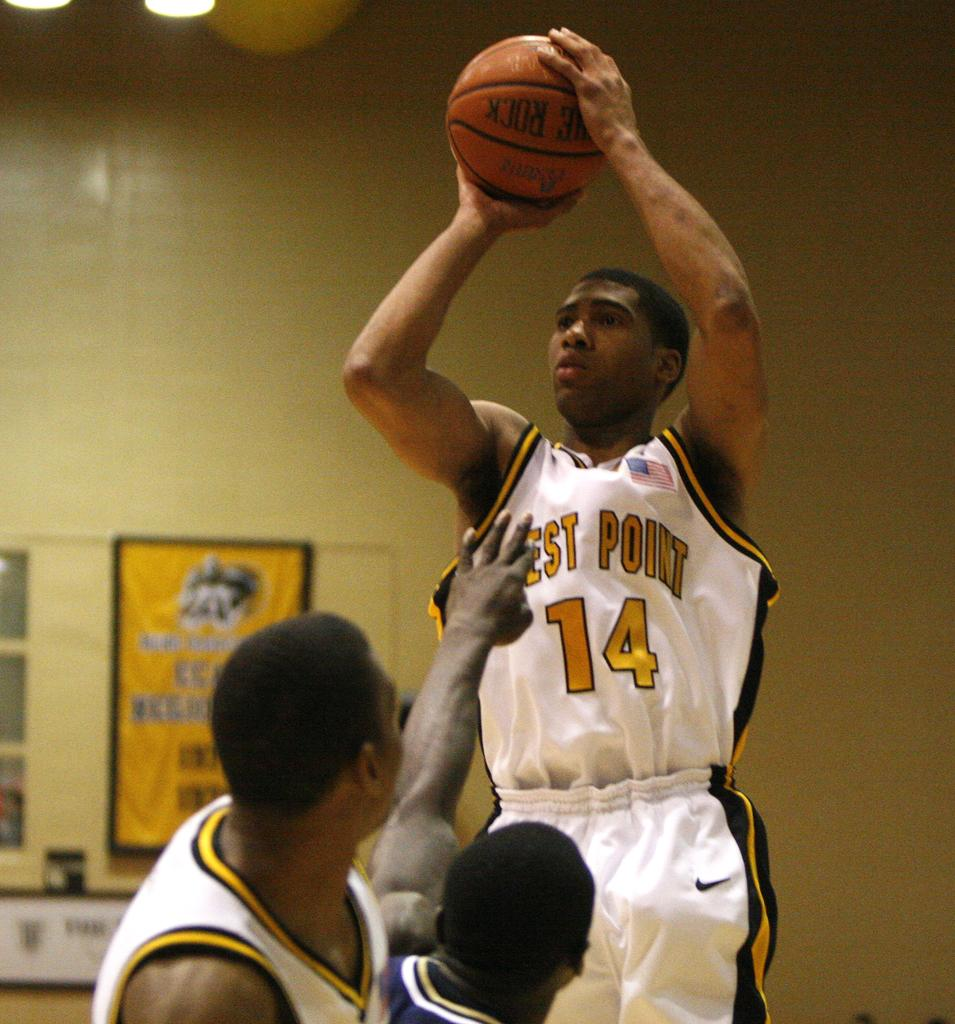<image>
Write a terse but informative summary of the picture. a basketball player from west point is aiming to make a basket 